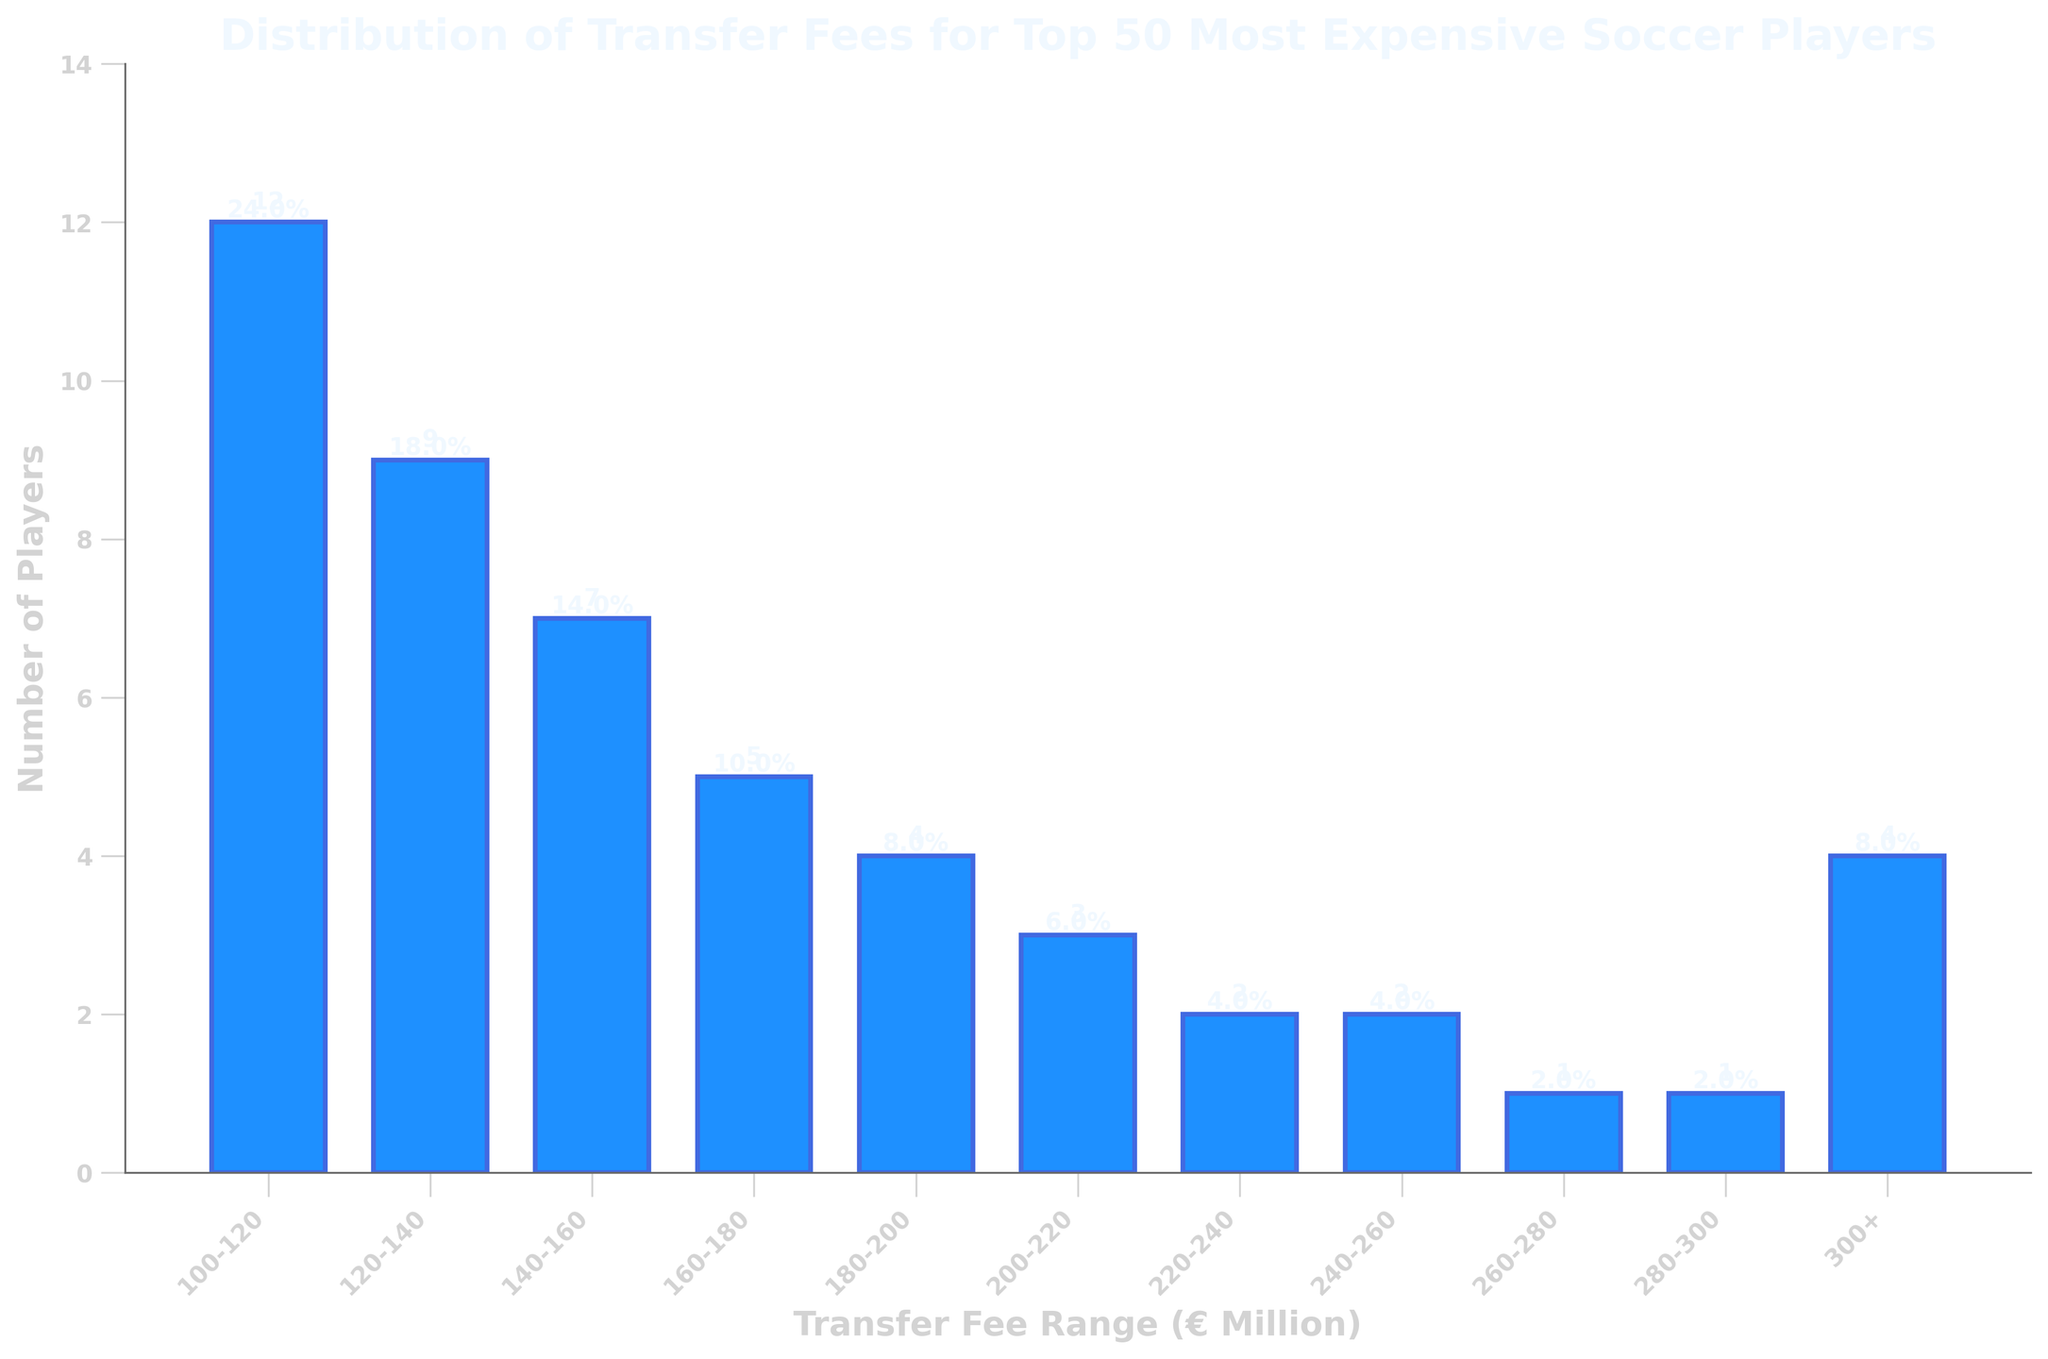What's the range with the highest number of players? The range with the highest number of players can be observed by looking at the tallest bar in the bar chart. The range 100-120 has the tallest bar, indicating it has the highest number of players.
Answer: 100-120 How many players have transfer fees above 200 million? Add the number of players in the transfer fee ranges 200-220, 220-240, 240-260, 260-280, 280-300, and 300+. Those values are 3 + 2 + 2 + 1 + 1 + 4, which totals 13 players.
Answer: 13 Which transfer fee range contains the median-most expensive player? Since there are 50 players, the median position would be the average of the 25th and 26th players' positions. Counting from the lowest fee range upwards: 12 (100-120) + 9 (120-140) + 7 (140-160) + 5 (160-180) = 33 players. This means the 25th and 26th players are in the 140-160 range.
Answer: 140-160 Compare the number of players with transfer fees in the 120-140 range to those in the 160-180 range. The number of players in the 120-140 range is 9, while the number of players in the 160-180 range is 5. Therefore, there are more players in the 120-140 range compared to the 160-180 range.
Answer: 9 > 5 What is the sum of the number of players in the 200-220 and 220-240 ranges? Add the number of players in the 200-220 and 220-240 ranges: 3 (200-220) + 2 (220-240) = 5 players.
Answer: 5 How many players fall into the lowest transfer fee range? Observe the bar corresponding to the 100-120 transfer fee range, which shows the number of players is 12.
Answer: 12 Identify the transfer fee range where the least number of players fall. The bar chart shows that the ranges 260-280 and 280-300 each have only 1 player, which is the least number of players.
Answer: 260-280 or 280-300 Describe the visual difference between the bars representing the 140-160 range and the 240-260 range. The bar for the 140-160 range is taller than the bar for the 240-260 range, indicating a higher number of players in the 140-160 range.
Answer: 140-160 is taller What percentage of players have transfer fees in the 160-180 range? Divide the number of players in the 160-180 range by the total number of players (50), then multiply by 100: (5/50)*100 = 10%.
Answer: 10% Determine the total number of players with transfer fees less than 160 million. Sum the number of players in the 100-120, 120-140, and 140-160 ranges: 12 + 9 + 7 = 28 players.
Answer: 28 